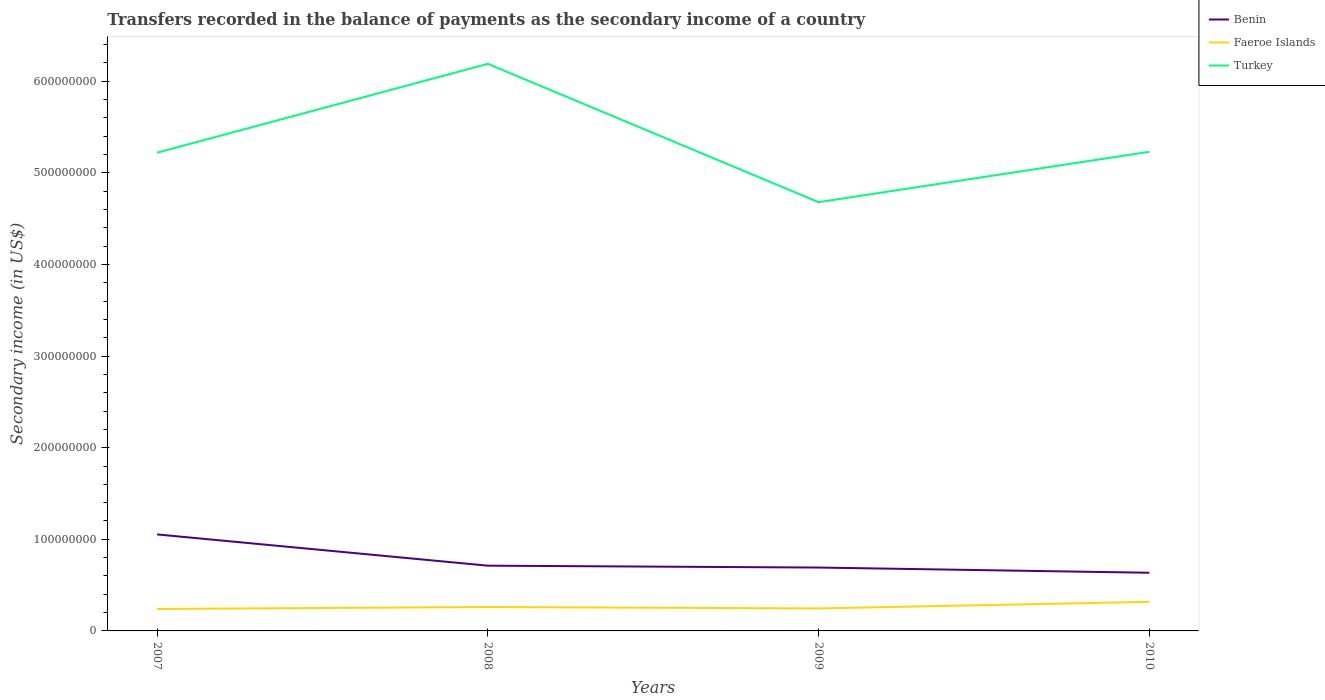How many different coloured lines are there?
Provide a short and direct response. 3. Is the number of lines equal to the number of legend labels?
Provide a succinct answer. Yes. Across all years, what is the maximum secondary income of in Faeroe Islands?
Your response must be concise. 2.40e+07. What is the total secondary income of in Faeroe Islands in the graph?
Offer a terse response. -5.65e+06. What is the difference between the highest and the second highest secondary income of in Benin?
Provide a short and direct response. 4.18e+07. What is the difference between the highest and the lowest secondary income of in Faeroe Islands?
Offer a very short reply. 1. Is the secondary income of in Faeroe Islands strictly greater than the secondary income of in Benin over the years?
Ensure brevity in your answer.  Yes. How many lines are there?
Make the answer very short. 3. How many years are there in the graph?
Ensure brevity in your answer.  4. Are the values on the major ticks of Y-axis written in scientific E-notation?
Your answer should be very brief. No. Does the graph contain grids?
Your answer should be very brief. No. Where does the legend appear in the graph?
Provide a short and direct response. Top right. What is the title of the graph?
Offer a very short reply. Transfers recorded in the balance of payments as the secondary income of a country. What is the label or title of the Y-axis?
Provide a succinct answer. Secondary income (in US$). What is the Secondary income (in US$) of Benin in 2007?
Your response must be concise. 1.05e+08. What is the Secondary income (in US$) of Faeroe Islands in 2007?
Provide a succinct answer. 2.40e+07. What is the Secondary income (in US$) of Turkey in 2007?
Make the answer very short. 5.22e+08. What is the Secondary income (in US$) of Benin in 2008?
Your answer should be compact. 7.12e+07. What is the Secondary income (in US$) in Faeroe Islands in 2008?
Provide a succinct answer. 2.61e+07. What is the Secondary income (in US$) of Turkey in 2008?
Offer a terse response. 6.19e+08. What is the Secondary income (in US$) of Benin in 2009?
Keep it short and to the point. 6.92e+07. What is the Secondary income (in US$) in Faeroe Islands in 2009?
Ensure brevity in your answer.  2.45e+07. What is the Secondary income (in US$) of Turkey in 2009?
Offer a terse response. 4.68e+08. What is the Secondary income (in US$) in Benin in 2010?
Keep it short and to the point. 6.35e+07. What is the Secondary income (in US$) of Faeroe Islands in 2010?
Your answer should be compact. 3.17e+07. What is the Secondary income (in US$) of Turkey in 2010?
Your answer should be compact. 5.23e+08. Across all years, what is the maximum Secondary income (in US$) of Benin?
Keep it short and to the point. 1.05e+08. Across all years, what is the maximum Secondary income (in US$) of Faeroe Islands?
Provide a succinct answer. 3.17e+07. Across all years, what is the maximum Secondary income (in US$) of Turkey?
Ensure brevity in your answer.  6.19e+08. Across all years, what is the minimum Secondary income (in US$) of Benin?
Offer a very short reply. 6.35e+07. Across all years, what is the minimum Secondary income (in US$) in Faeroe Islands?
Your answer should be very brief. 2.40e+07. Across all years, what is the minimum Secondary income (in US$) of Turkey?
Your response must be concise. 4.68e+08. What is the total Secondary income (in US$) of Benin in the graph?
Give a very brief answer. 3.09e+08. What is the total Secondary income (in US$) of Faeroe Islands in the graph?
Ensure brevity in your answer.  1.06e+08. What is the total Secondary income (in US$) in Turkey in the graph?
Your answer should be compact. 2.13e+09. What is the difference between the Secondary income (in US$) of Benin in 2007 and that in 2008?
Ensure brevity in your answer.  3.41e+07. What is the difference between the Secondary income (in US$) of Faeroe Islands in 2007 and that in 2008?
Your response must be concise. -2.14e+06. What is the difference between the Secondary income (in US$) of Turkey in 2007 and that in 2008?
Offer a terse response. -9.70e+07. What is the difference between the Secondary income (in US$) in Benin in 2007 and that in 2009?
Your answer should be very brief. 3.62e+07. What is the difference between the Secondary income (in US$) in Faeroe Islands in 2007 and that in 2009?
Ensure brevity in your answer.  -5.79e+05. What is the difference between the Secondary income (in US$) in Turkey in 2007 and that in 2009?
Your response must be concise. 5.40e+07. What is the difference between the Secondary income (in US$) of Benin in 2007 and that in 2010?
Give a very brief answer. 4.18e+07. What is the difference between the Secondary income (in US$) in Faeroe Islands in 2007 and that in 2010?
Provide a short and direct response. -7.79e+06. What is the difference between the Secondary income (in US$) of Benin in 2008 and that in 2009?
Ensure brevity in your answer.  2.05e+06. What is the difference between the Secondary income (in US$) in Faeroe Islands in 2008 and that in 2009?
Ensure brevity in your answer.  1.56e+06. What is the difference between the Secondary income (in US$) in Turkey in 2008 and that in 2009?
Your answer should be very brief. 1.51e+08. What is the difference between the Secondary income (in US$) in Benin in 2008 and that in 2010?
Offer a terse response. 7.72e+06. What is the difference between the Secondary income (in US$) in Faeroe Islands in 2008 and that in 2010?
Give a very brief answer. -5.65e+06. What is the difference between the Secondary income (in US$) of Turkey in 2008 and that in 2010?
Offer a terse response. 9.60e+07. What is the difference between the Secondary income (in US$) in Benin in 2009 and that in 2010?
Keep it short and to the point. 5.68e+06. What is the difference between the Secondary income (in US$) in Faeroe Islands in 2009 and that in 2010?
Provide a succinct answer. -7.21e+06. What is the difference between the Secondary income (in US$) in Turkey in 2009 and that in 2010?
Your response must be concise. -5.50e+07. What is the difference between the Secondary income (in US$) in Benin in 2007 and the Secondary income (in US$) in Faeroe Islands in 2008?
Provide a short and direct response. 7.92e+07. What is the difference between the Secondary income (in US$) of Benin in 2007 and the Secondary income (in US$) of Turkey in 2008?
Make the answer very short. -5.14e+08. What is the difference between the Secondary income (in US$) of Faeroe Islands in 2007 and the Secondary income (in US$) of Turkey in 2008?
Your response must be concise. -5.95e+08. What is the difference between the Secondary income (in US$) of Benin in 2007 and the Secondary income (in US$) of Faeroe Islands in 2009?
Give a very brief answer. 8.08e+07. What is the difference between the Secondary income (in US$) of Benin in 2007 and the Secondary income (in US$) of Turkey in 2009?
Your answer should be very brief. -3.63e+08. What is the difference between the Secondary income (in US$) in Faeroe Islands in 2007 and the Secondary income (in US$) in Turkey in 2009?
Give a very brief answer. -4.44e+08. What is the difference between the Secondary income (in US$) of Benin in 2007 and the Secondary income (in US$) of Faeroe Islands in 2010?
Your response must be concise. 7.36e+07. What is the difference between the Secondary income (in US$) in Benin in 2007 and the Secondary income (in US$) in Turkey in 2010?
Your answer should be very brief. -4.18e+08. What is the difference between the Secondary income (in US$) in Faeroe Islands in 2007 and the Secondary income (in US$) in Turkey in 2010?
Keep it short and to the point. -4.99e+08. What is the difference between the Secondary income (in US$) of Benin in 2008 and the Secondary income (in US$) of Faeroe Islands in 2009?
Your answer should be compact. 4.67e+07. What is the difference between the Secondary income (in US$) of Benin in 2008 and the Secondary income (in US$) of Turkey in 2009?
Offer a terse response. -3.97e+08. What is the difference between the Secondary income (in US$) of Faeroe Islands in 2008 and the Secondary income (in US$) of Turkey in 2009?
Ensure brevity in your answer.  -4.42e+08. What is the difference between the Secondary income (in US$) of Benin in 2008 and the Secondary income (in US$) of Faeroe Islands in 2010?
Keep it short and to the point. 3.95e+07. What is the difference between the Secondary income (in US$) in Benin in 2008 and the Secondary income (in US$) in Turkey in 2010?
Provide a short and direct response. -4.52e+08. What is the difference between the Secondary income (in US$) in Faeroe Islands in 2008 and the Secondary income (in US$) in Turkey in 2010?
Make the answer very short. -4.97e+08. What is the difference between the Secondary income (in US$) in Benin in 2009 and the Secondary income (in US$) in Faeroe Islands in 2010?
Keep it short and to the point. 3.74e+07. What is the difference between the Secondary income (in US$) in Benin in 2009 and the Secondary income (in US$) in Turkey in 2010?
Your answer should be very brief. -4.54e+08. What is the difference between the Secondary income (in US$) of Faeroe Islands in 2009 and the Secondary income (in US$) of Turkey in 2010?
Keep it short and to the point. -4.98e+08. What is the average Secondary income (in US$) of Benin per year?
Ensure brevity in your answer.  7.73e+07. What is the average Secondary income (in US$) in Faeroe Islands per year?
Provide a succinct answer. 2.66e+07. What is the average Secondary income (in US$) of Turkey per year?
Ensure brevity in your answer.  5.33e+08. In the year 2007, what is the difference between the Secondary income (in US$) in Benin and Secondary income (in US$) in Faeroe Islands?
Offer a terse response. 8.14e+07. In the year 2007, what is the difference between the Secondary income (in US$) in Benin and Secondary income (in US$) in Turkey?
Ensure brevity in your answer.  -4.17e+08. In the year 2007, what is the difference between the Secondary income (in US$) of Faeroe Islands and Secondary income (in US$) of Turkey?
Your answer should be very brief. -4.98e+08. In the year 2008, what is the difference between the Secondary income (in US$) in Benin and Secondary income (in US$) in Faeroe Islands?
Offer a terse response. 4.51e+07. In the year 2008, what is the difference between the Secondary income (in US$) of Benin and Secondary income (in US$) of Turkey?
Ensure brevity in your answer.  -5.48e+08. In the year 2008, what is the difference between the Secondary income (in US$) of Faeroe Islands and Secondary income (in US$) of Turkey?
Provide a short and direct response. -5.93e+08. In the year 2009, what is the difference between the Secondary income (in US$) of Benin and Secondary income (in US$) of Faeroe Islands?
Provide a succinct answer. 4.46e+07. In the year 2009, what is the difference between the Secondary income (in US$) of Benin and Secondary income (in US$) of Turkey?
Offer a very short reply. -3.99e+08. In the year 2009, what is the difference between the Secondary income (in US$) of Faeroe Islands and Secondary income (in US$) of Turkey?
Offer a terse response. -4.43e+08. In the year 2010, what is the difference between the Secondary income (in US$) of Benin and Secondary income (in US$) of Faeroe Islands?
Your response must be concise. 3.17e+07. In the year 2010, what is the difference between the Secondary income (in US$) in Benin and Secondary income (in US$) in Turkey?
Give a very brief answer. -4.60e+08. In the year 2010, what is the difference between the Secondary income (in US$) in Faeroe Islands and Secondary income (in US$) in Turkey?
Your response must be concise. -4.91e+08. What is the ratio of the Secondary income (in US$) of Benin in 2007 to that in 2008?
Your answer should be compact. 1.48. What is the ratio of the Secondary income (in US$) in Faeroe Islands in 2007 to that in 2008?
Your answer should be compact. 0.92. What is the ratio of the Secondary income (in US$) of Turkey in 2007 to that in 2008?
Provide a short and direct response. 0.84. What is the ratio of the Secondary income (in US$) of Benin in 2007 to that in 2009?
Provide a short and direct response. 1.52. What is the ratio of the Secondary income (in US$) in Faeroe Islands in 2007 to that in 2009?
Make the answer very short. 0.98. What is the ratio of the Secondary income (in US$) in Turkey in 2007 to that in 2009?
Offer a terse response. 1.12. What is the ratio of the Secondary income (in US$) in Benin in 2007 to that in 2010?
Ensure brevity in your answer.  1.66. What is the ratio of the Secondary income (in US$) of Faeroe Islands in 2007 to that in 2010?
Your answer should be compact. 0.75. What is the ratio of the Secondary income (in US$) in Benin in 2008 to that in 2009?
Offer a very short reply. 1.03. What is the ratio of the Secondary income (in US$) in Faeroe Islands in 2008 to that in 2009?
Your answer should be very brief. 1.06. What is the ratio of the Secondary income (in US$) of Turkey in 2008 to that in 2009?
Provide a short and direct response. 1.32. What is the ratio of the Secondary income (in US$) of Benin in 2008 to that in 2010?
Ensure brevity in your answer.  1.12. What is the ratio of the Secondary income (in US$) of Faeroe Islands in 2008 to that in 2010?
Your response must be concise. 0.82. What is the ratio of the Secondary income (in US$) in Turkey in 2008 to that in 2010?
Your answer should be compact. 1.18. What is the ratio of the Secondary income (in US$) in Benin in 2009 to that in 2010?
Give a very brief answer. 1.09. What is the ratio of the Secondary income (in US$) of Faeroe Islands in 2009 to that in 2010?
Provide a succinct answer. 0.77. What is the ratio of the Secondary income (in US$) of Turkey in 2009 to that in 2010?
Provide a succinct answer. 0.89. What is the difference between the highest and the second highest Secondary income (in US$) of Benin?
Your response must be concise. 3.41e+07. What is the difference between the highest and the second highest Secondary income (in US$) in Faeroe Islands?
Offer a terse response. 5.65e+06. What is the difference between the highest and the second highest Secondary income (in US$) in Turkey?
Ensure brevity in your answer.  9.60e+07. What is the difference between the highest and the lowest Secondary income (in US$) of Benin?
Your answer should be very brief. 4.18e+07. What is the difference between the highest and the lowest Secondary income (in US$) in Faeroe Islands?
Provide a short and direct response. 7.79e+06. What is the difference between the highest and the lowest Secondary income (in US$) of Turkey?
Your response must be concise. 1.51e+08. 